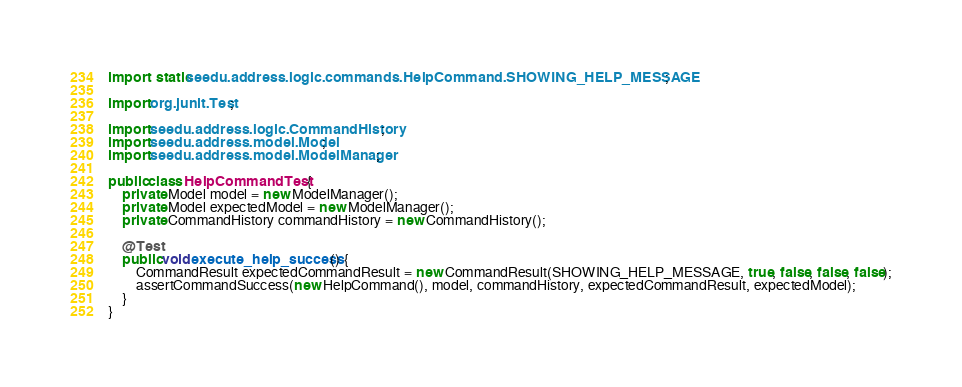Convert code to text. <code><loc_0><loc_0><loc_500><loc_500><_Java_>import static seedu.address.logic.commands.HelpCommand.SHOWING_HELP_MESSAGE;

import org.junit.Test;

import seedu.address.logic.CommandHistory;
import seedu.address.model.Model;
import seedu.address.model.ModelManager;

public class HelpCommandTest {
    private Model model = new ModelManager();
    private Model expectedModel = new ModelManager();
    private CommandHistory commandHistory = new CommandHistory();

    @Test
    public void execute_help_success() {
        CommandResult expectedCommandResult = new CommandResult(SHOWING_HELP_MESSAGE, true, false, false, false);
        assertCommandSuccess(new HelpCommand(), model, commandHistory, expectedCommandResult, expectedModel);
    }
}
</code> 